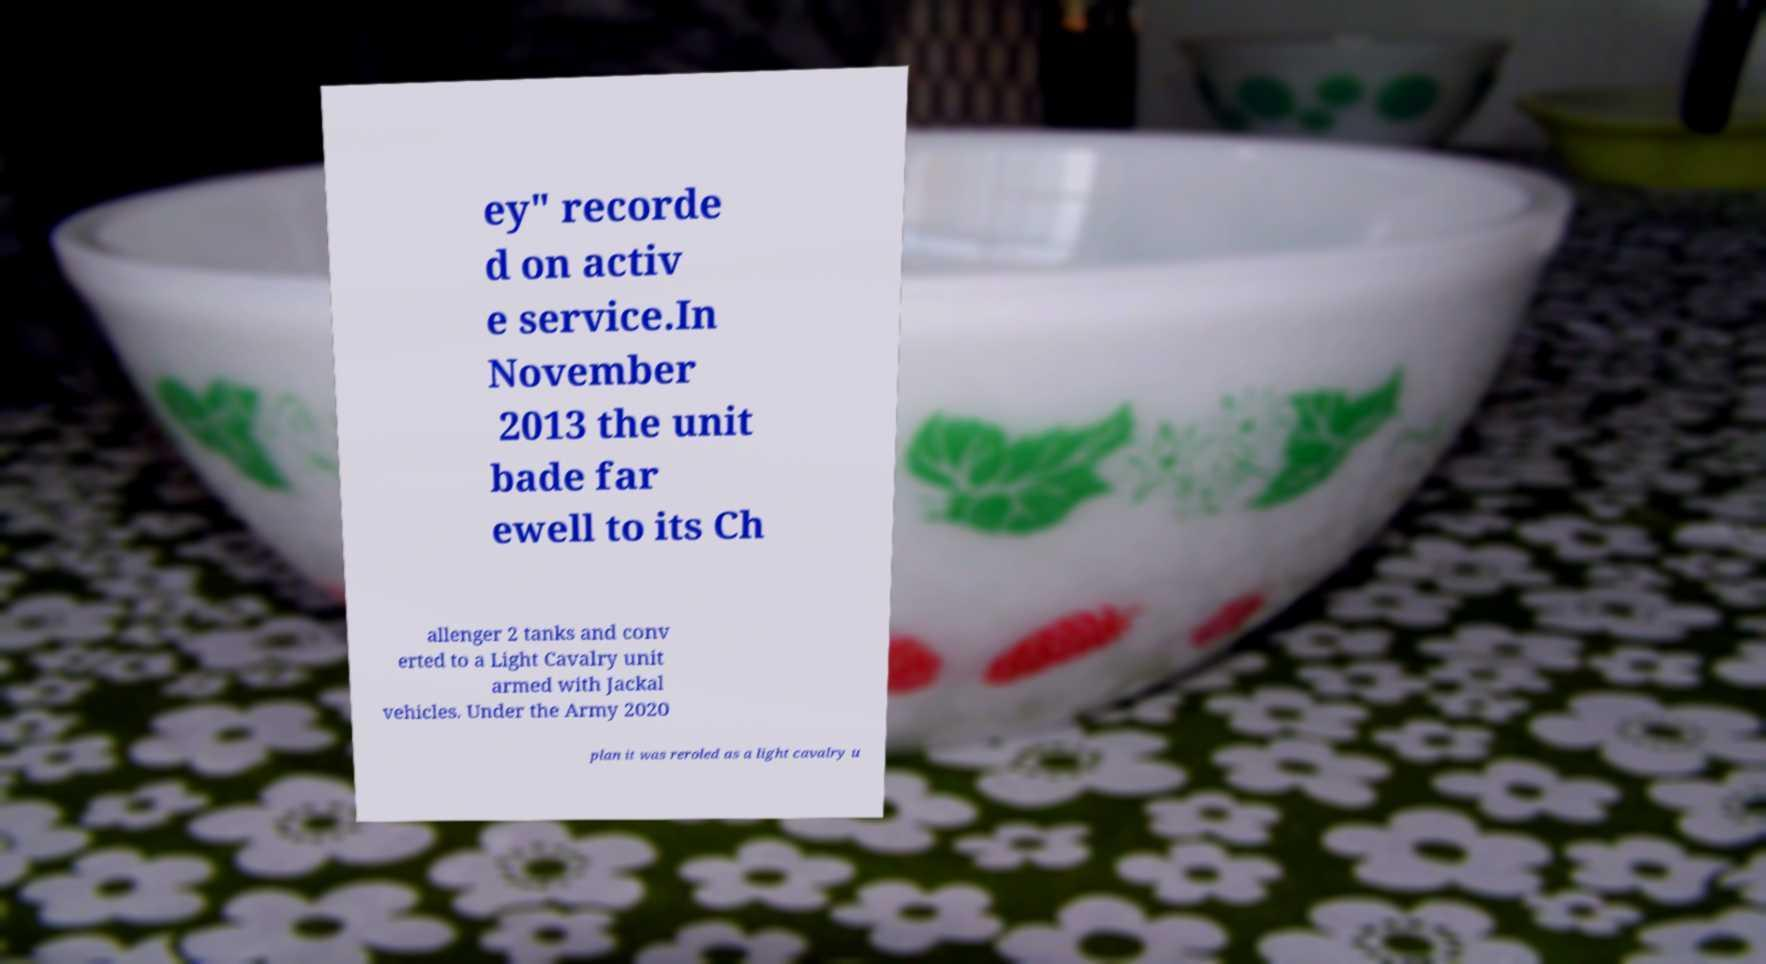Please read and relay the text visible in this image. What does it say? ey" recorde d on activ e service.In November 2013 the unit bade far ewell to its Ch allenger 2 tanks and conv erted to a Light Cavalry unit armed with Jackal vehicles. Under the Army 2020 plan it was reroled as a light cavalry u 